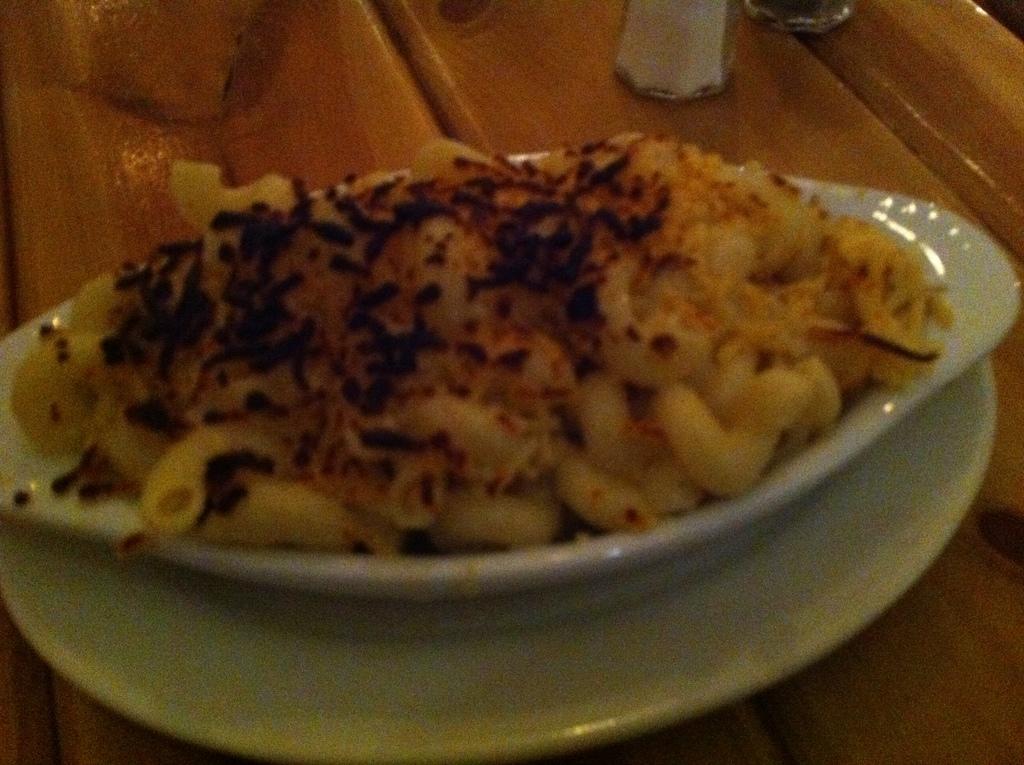Could you give a brief overview of what you see in this image? In this image we can pasta is decorated in a white color dish. 